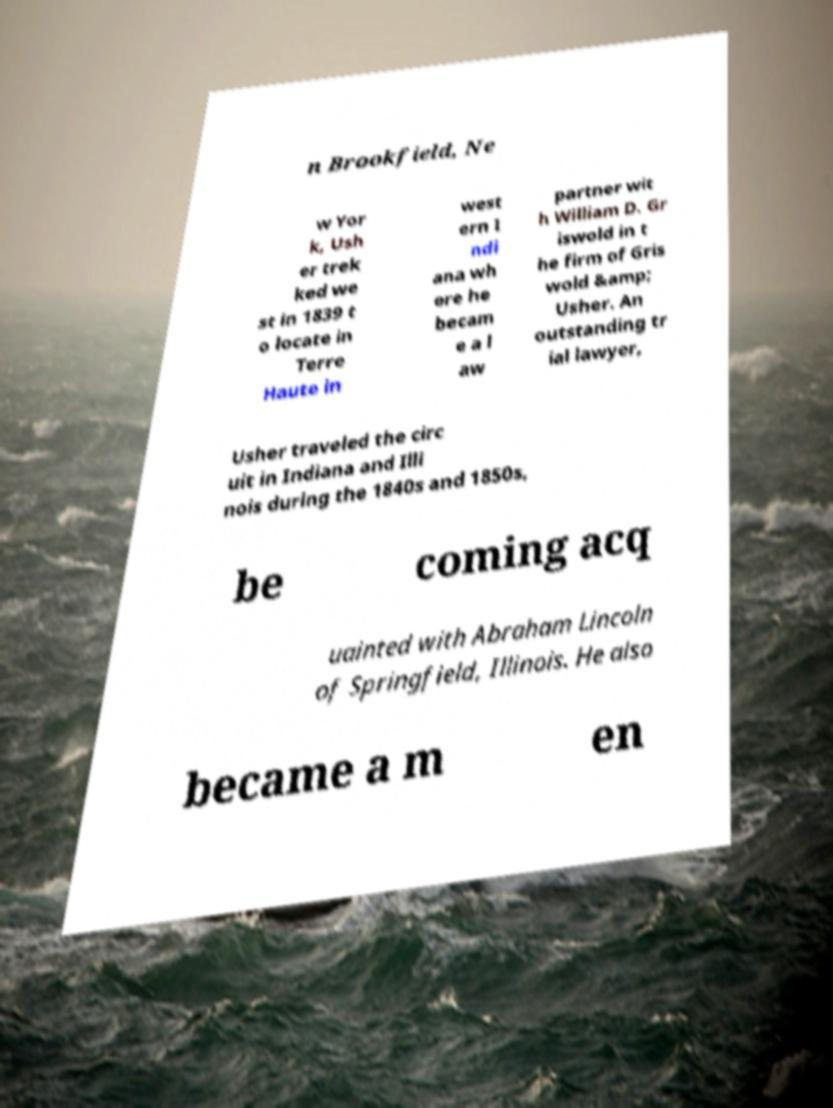Can you accurately transcribe the text from the provided image for me? n Brookfield, Ne w Yor k, Ush er trek ked we st in 1839 t o locate in Terre Haute in west ern I ndi ana wh ere he becam e a l aw partner wit h William D. Gr iswold in t he firm of Gris wold &amp; Usher. An outstanding tr ial lawyer, Usher traveled the circ uit in Indiana and Illi nois during the 1840s and 1850s, be coming acq uainted with Abraham Lincoln of Springfield, Illinois. He also became a m en 